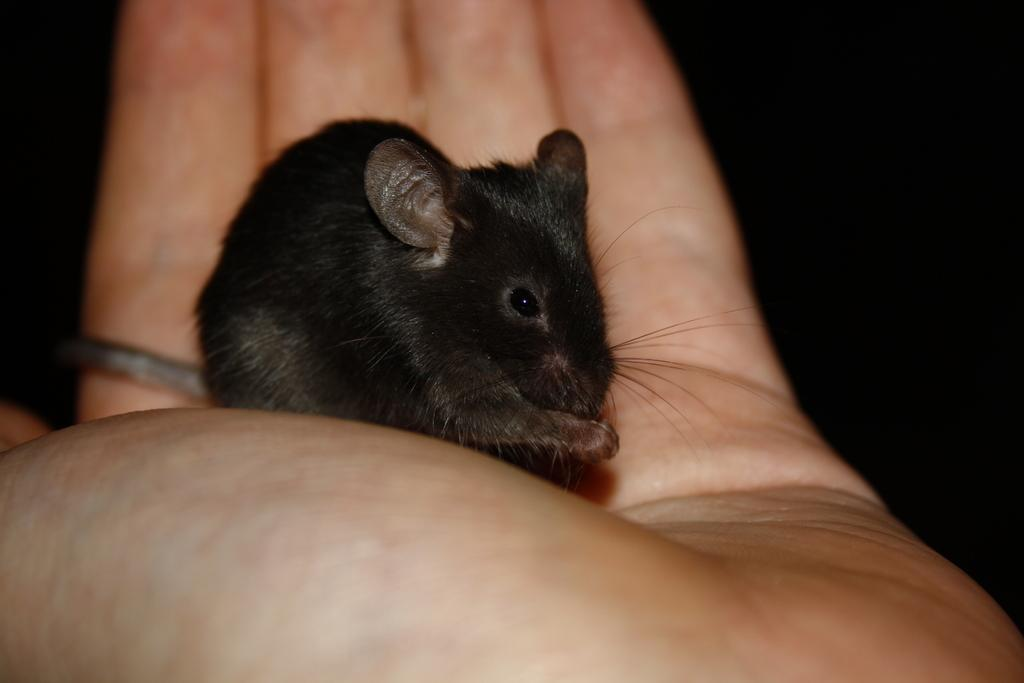What type of animal is in the image? There is a black color rat in the image. Where is the rat located in the image? The rat is on a person's hand. What color is the background of the image? The background of the image is black. What type of badge is the rat wearing in the image? There is no badge present in the image; the rat is simply on a person's hand. 